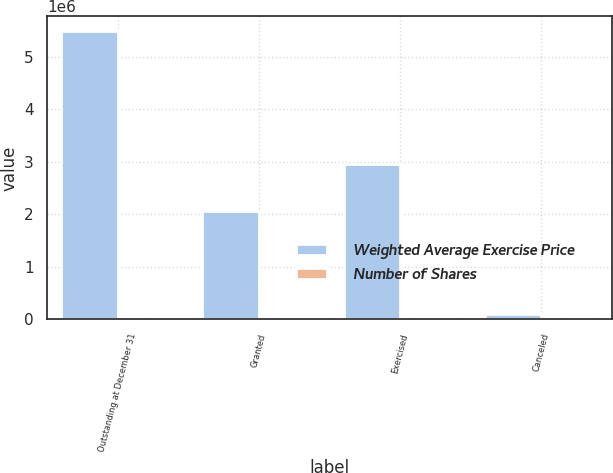<chart> <loc_0><loc_0><loc_500><loc_500><stacked_bar_chart><ecel><fcel>Outstanding at December 31<fcel>Granted<fcel>Exercised<fcel>Canceled<nl><fcel>Weighted Average Exercise Price<fcel>5.4955e+06<fcel>2.0673e+06<fcel>2.96355e+06<fcel>96886<nl><fcel>Number of Shares<fcel>49.43<fcel>33.28<fcel>17.17<fcel>30.78<nl></chart> 